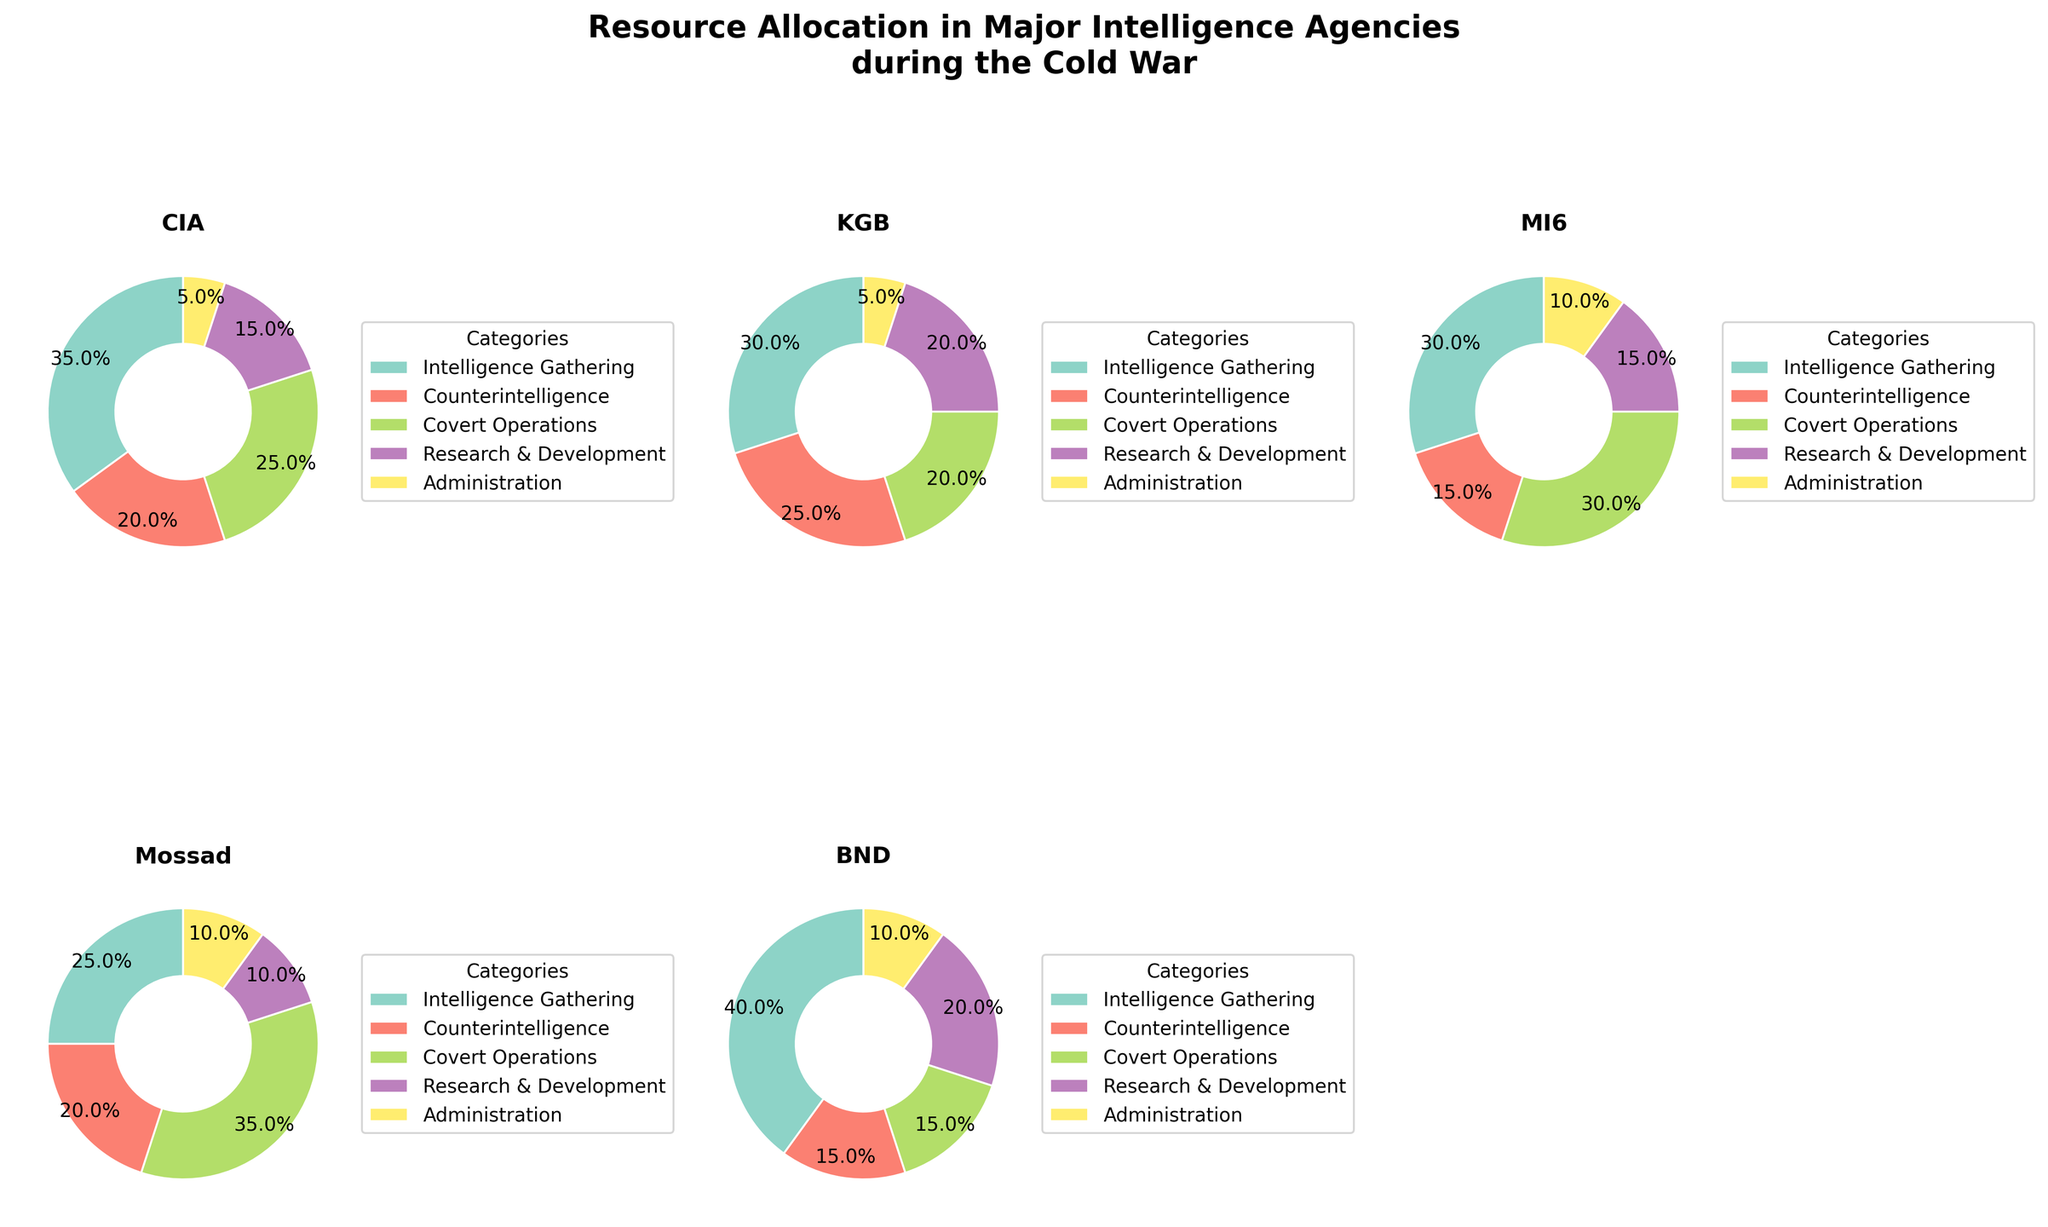What's the overall title of the figure? The title is displayed at the top of the figure and should succinctly describe the content of the plots. Here, the title helps set the context for what the pie charts represent.
Answer: Resource Allocation in Major Intelligence Agencies during the Cold War Which agency allocated the highest percentage of resources to Intelligence Gathering? Look at the pie charts to identify which agency's section for Intelligence Gathering is the largest. The CIA has the largest section for Intelligence Gathering with 35%.
Answer: CIA How much more did Mossad spend on Covert Operations compared to MI6? Locate Mossad's and MI6's Covert Operations sections in their respective pie charts. Mossad allocated 35%, and MI6 allocated 30%. The difference is 35% - 30% = 5%.
Answer: 5% Which agencies allocated an equal percentage of resources to Administration? Find the Administration sections in each pie chart and compare the percentages. Both the CIA and KGB allocated 5%.
Answer: CIA and KGB What's the sum of the percentages for Counterintelligence and R&D in the KGB? Locate the KGB pie chart and find the percentages for Counterintelligence and Research & Development. The values are 25% for Counterintelligence and 20% for R&D, so the sum is 25% + 20% = 45%.
Answer: 45% Which agency has the most balanced allocation among all categories? To determine balance, look for the pie chart with the most evenly distributed slices. The BND seems to have the most balanced distribution with percentages of 40, 15, 15, 20, and 10.
Answer: BND Which category received the smallest allocation from the CIA, and what percentage was it? Focus on the CIA pie chart and identify the smallest slice, which is for Administration at 5%.
Answer: Administration, 5% Compare the total percentage allocated to Counterintelligence by the CIA, KGB, and MI6. Which agency allocated the most and which the least? Look at the pie charts for CIA (20%), KGB (25%), and MI6 (15%). The KGB allocated the most, and MI6 the least.
Answer: KGB the most, MI6 the least What's the difference in percentage allocation to Research & Development between the agency with the highest and lowest allocation in this category? Find the Research & Development sections and identify the highest (KGB and BND at 20%) and lowest (Mossad at 10%). The difference is 20% - 10% = 10%.
Answer: 10% Which agency allocated more resources to Covert Operations, MI6 or Mossad? Compare the Covert Operations sections in MI6 and Mossad pie charts. MI6 allocated 30%, and Mossad allocated 35%.
Answer: Mossad 